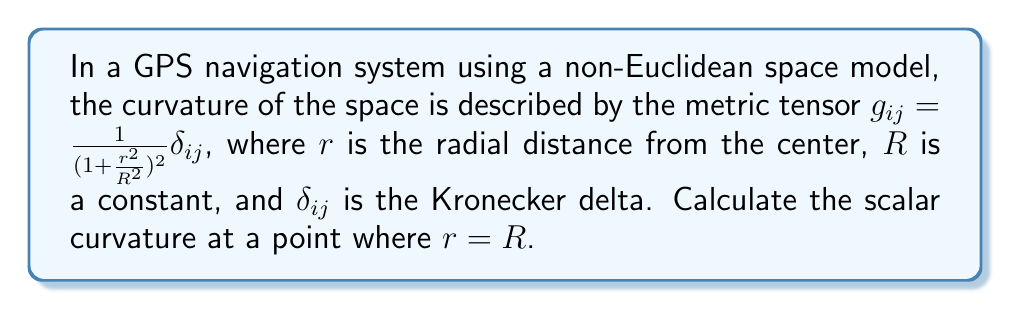Could you help me with this problem? To calculate the scalar curvature, we'll follow these steps:

1) The scalar curvature is given by $R = g^{ij}R_{ij}$, where $R_{ij}$ is the Ricci tensor and $g^{ij}$ is the inverse metric tensor.

2) First, let's calculate the inverse metric tensor:
   $g^{ij} = (1 + \frac{r^2}{R^2})^2 \delta^{ij}$

3) The Ricci tensor for this metric is:
   $R_{ij} = \frac{2}{R^2} \left(1 + \frac{r^2}{R^2}\right) g_{ij}$

4) Substituting these into the scalar curvature formula:
   $R = g^{ij}R_{ij} = (1 + \frac{r^2}{R^2})^2 \delta^{ij} \cdot \frac{2}{R^2} \left(1 + \frac{r^2}{R^2}\right) g_{ij}$

5) Simplifying:
   $R = \frac{2}{R^2} \left(1 + \frac{r^2}{R^2}\right)^3 \delta^{ij} \delta_{ij}$

6) Note that $\delta^{ij} \delta_{ij} = 3$ in 3D space.

7) Therefore:
   $R = \frac{6}{R^2} \left(1 + \frac{r^2}{R^2}\right)^3$

8) At $r = R$:
   $R = \frac{6}{R^2} (1 + 1)^3 = \frac{48}{R^2}$
Answer: $\frac{48}{R^2}$ 